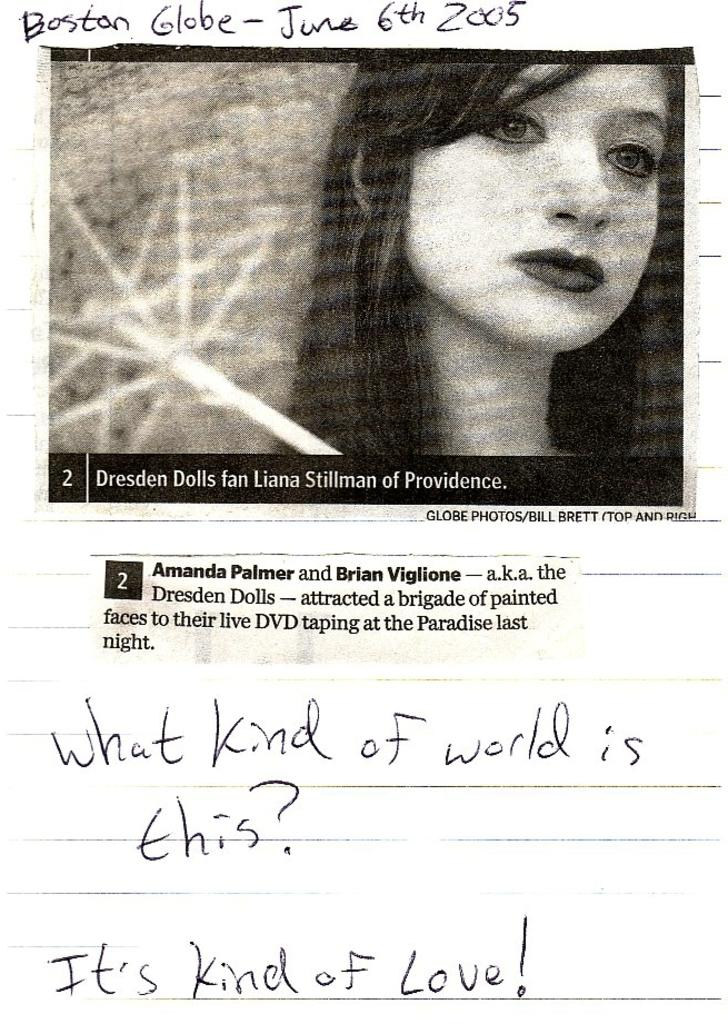What type of visual is the image in question? The image is a poster. What can be found on the poster besides the image? There is text on the poster. What is the main image on the poster? There is an image of a woman on the poster. What else can be seen in the image besides the woman and text? There are objects present in the image. Is the stranger in the image reading a bottle? There is no stranger or bottle present in the image. 